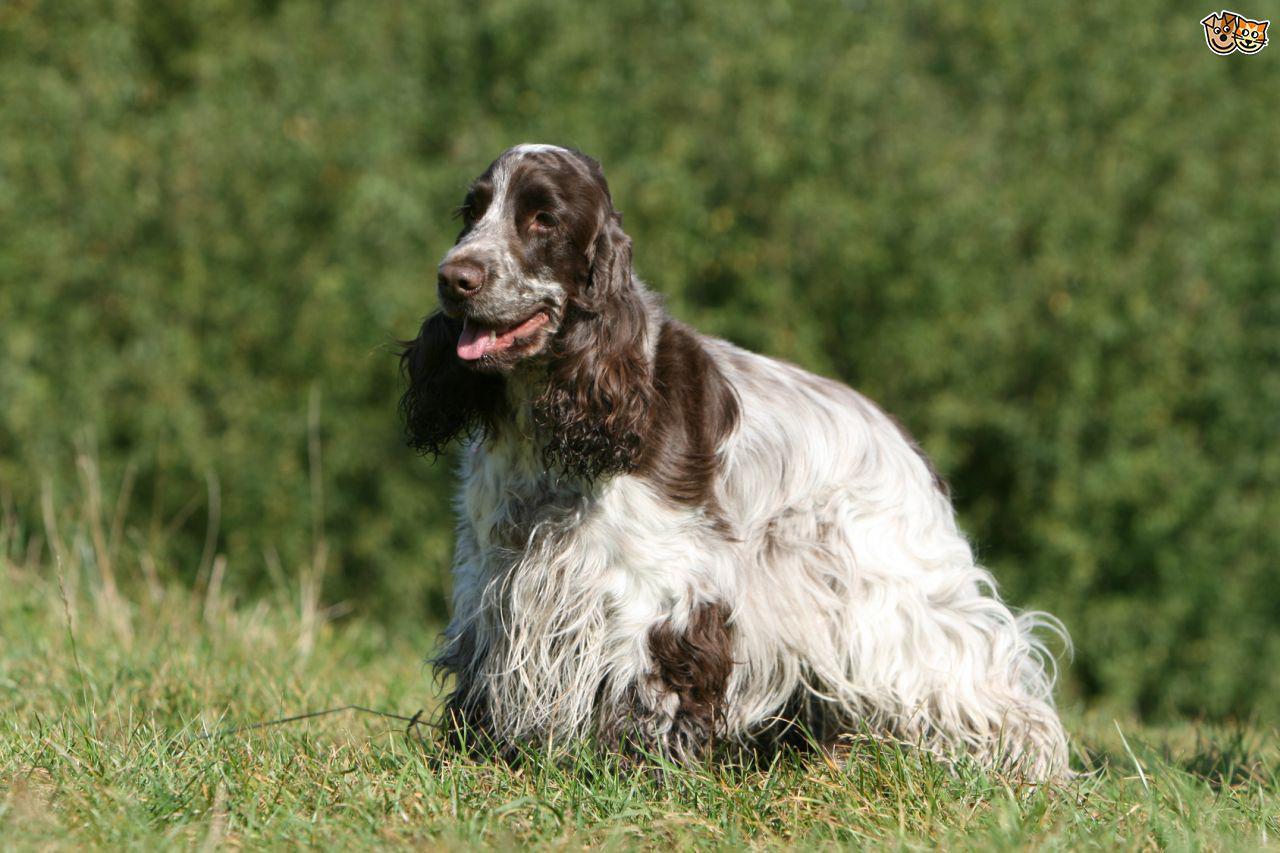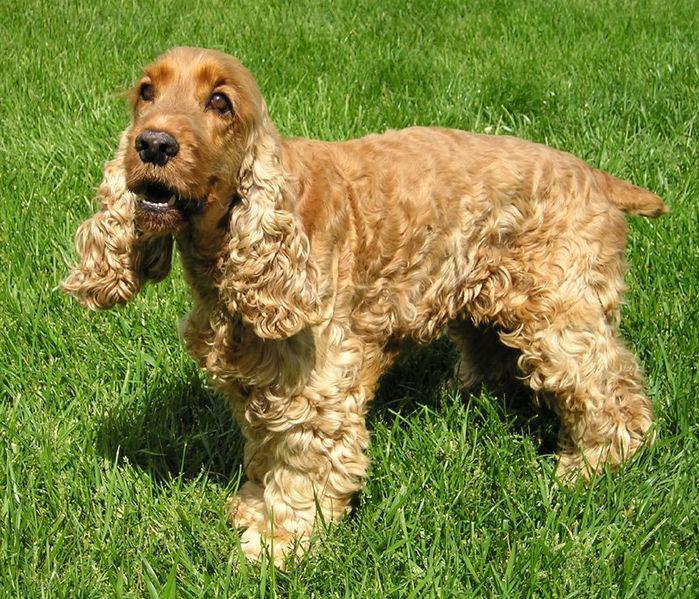The first image is the image on the left, the second image is the image on the right. Given the left and right images, does the statement "The right image features one orange cocker spaniel standing on all fours in profile, and the left image features a spaniel with dark fur on the ears and eyes and lighter body fur." hold true? Answer yes or no. Yes. The first image is the image on the left, the second image is the image on the right. Assess this claim about the two images: "One dog's body is turned towards the right.". Correct or not? Answer yes or no. No. 